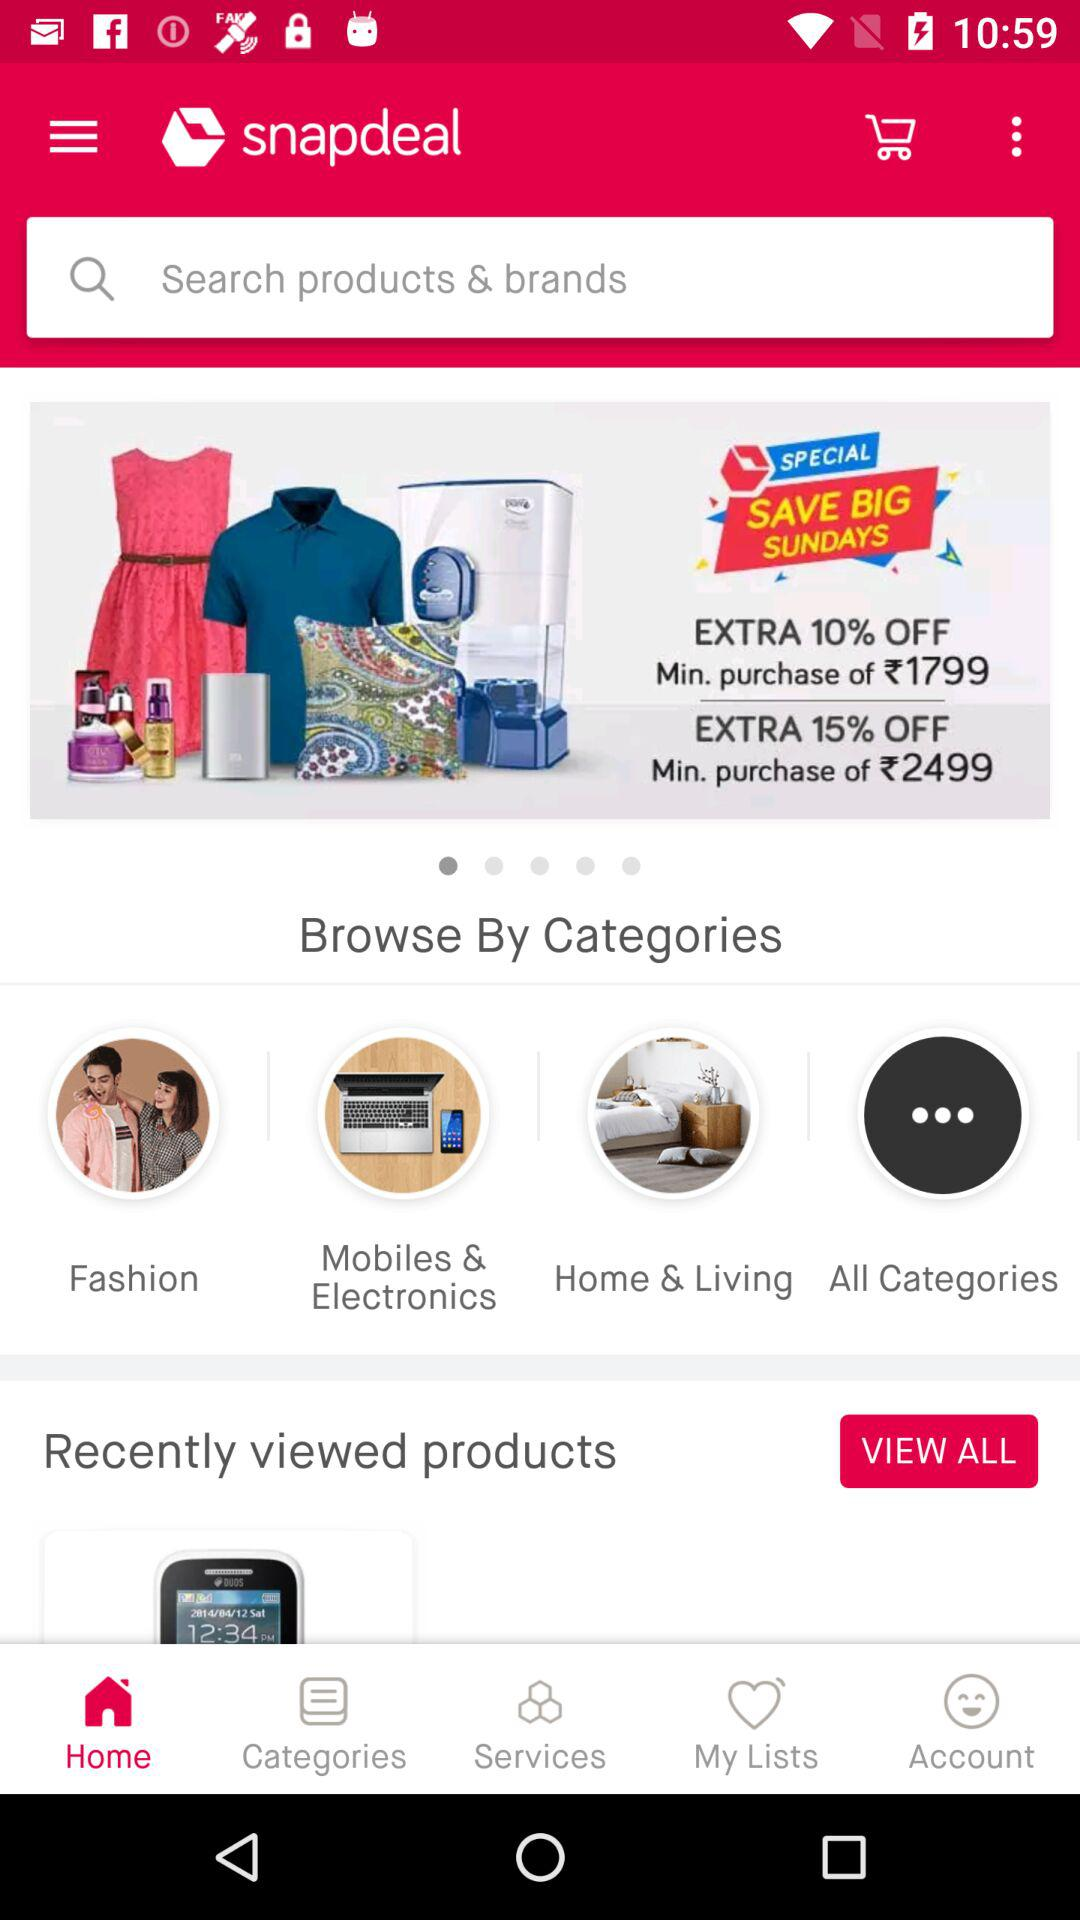How many products are currently in the Recently viewed products section?
Answer the question using a single word or phrase. 1 